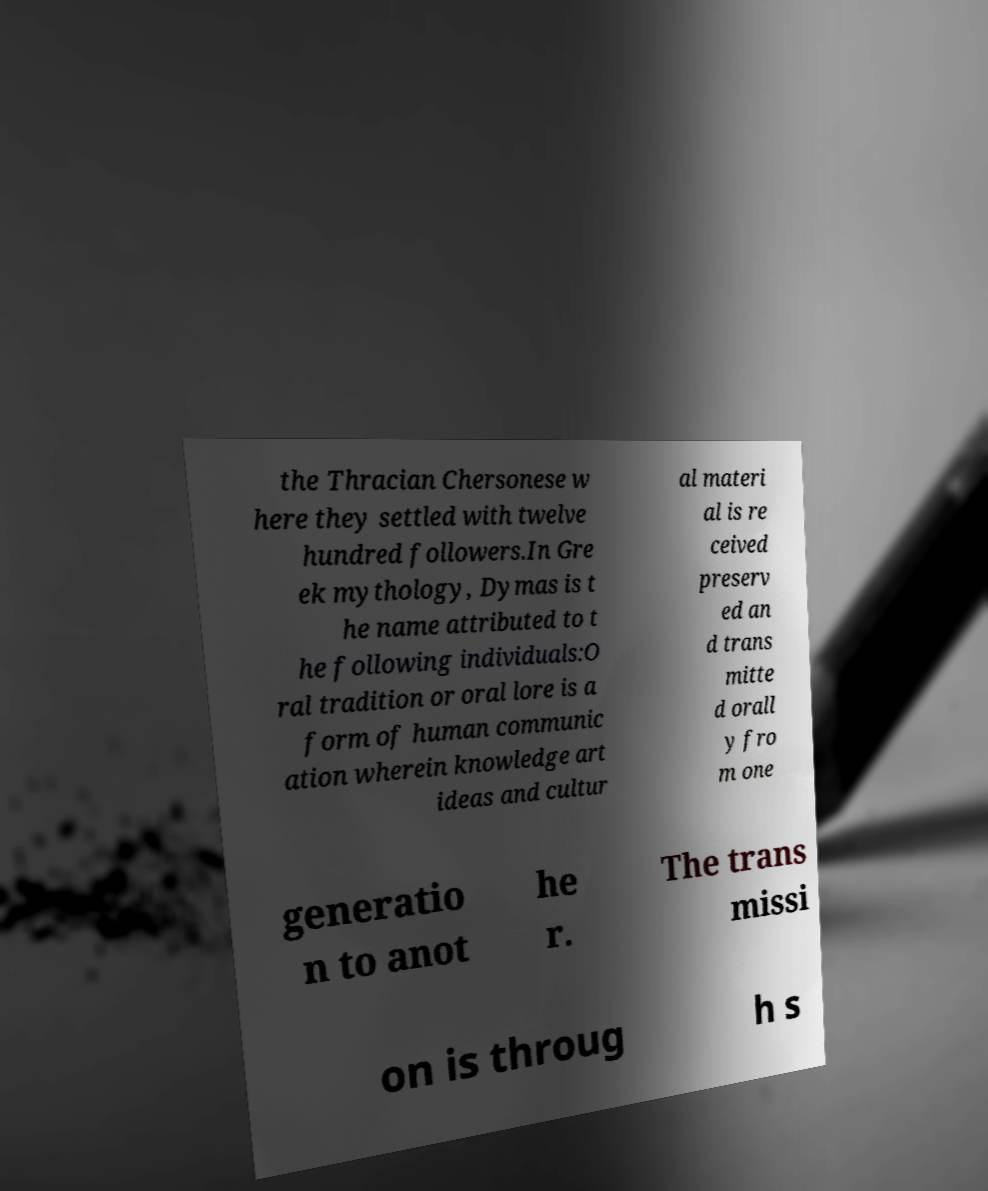There's text embedded in this image that I need extracted. Can you transcribe it verbatim? the Thracian Chersonese w here they settled with twelve hundred followers.In Gre ek mythology, Dymas is t he name attributed to t he following individuals:O ral tradition or oral lore is a form of human communic ation wherein knowledge art ideas and cultur al materi al is re ceived preserv ed an d trans mitte d orall y fro m one generatio n to anot he r. The trans missi on is throug h s 